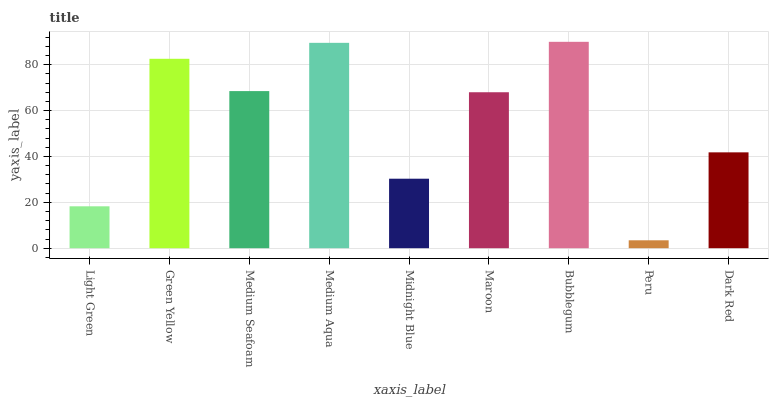Is Peru the minimum?
Answer yes or no. Yes. Is Bubblegum the maximum?
Answer yes or no. Yes. Is Green Yellow the minimum?
Answer yes or no. No. Is Green Yellow the maximum?
Answer yes or no. No. Is Green Yellow greater than Light Green?
Answer yes or no. Yes. Is Light Green less than Green Yellow?
Answer yes or no. Yes. Is Light Green greater than Green Yellow?
Answer yes or no. No. Is Green Yellow less than Light Green?
Answer yes or no. No. Is Maroon the high median?
Answer yes or no. Yes. Is Maroon the low median?
Answer yes or no. Yes. Is Green Yellow the high median?
Answer yes or no. No. Is Medium Aqua the low median?
Answer yes or no. No. 